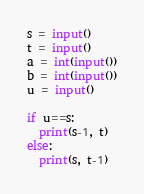<code> <loc_0><loc_0><loc_500><loc_500><_Python_>s = input()
t = input()
a = int(input())
b = int(input())
u = input()

if u==s:
  print(s-1, t)
else:
  print(s, t-1)</code> 